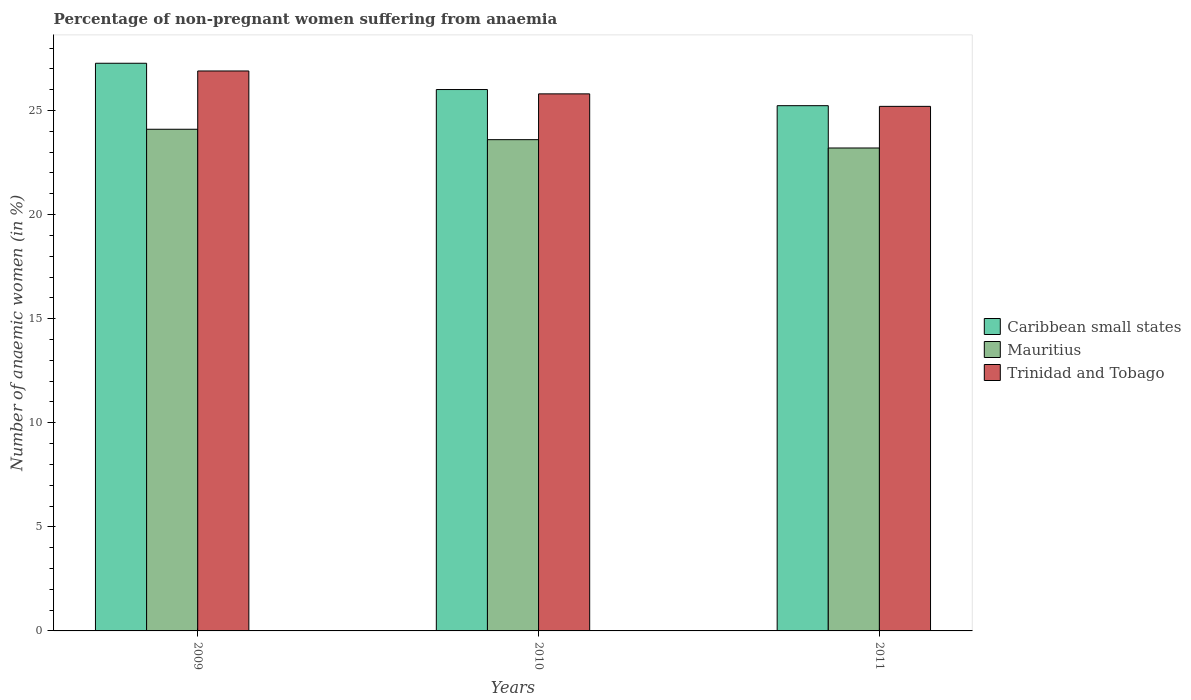Are the number of bars per tick equal to the number of legend labels?
Your answer should be very brief. Yes. What is the percentage of non-pregnant women suffering from anaemia in Trinidad and Tobago in 2010?
Provide a succinct answer. 25.8. Across all years, what is the maximum percentage of non-pregnant women suffering from anaemia in Caribbean small states?
Keep it short and to the point. 27.27. Across all years, what is the minimum percentage of non-pregnant women suffering from anaemia in Mauritius?
Provide a succinct answer. 23.2. What is the total percentage of non-pregnant women suffering from anaemia in Mauritius in the graph?
Your answer should be compact. 70.9. What is the difference between the percentage of non-pregnant women suffering from anaemia in Trinidad and Tobago in 2010 and that in 2011?
Offer a terse response. 0.6. What is the difference between the percentage of non-pregnant women suffering from anaemia in Caribbean small states in 2011 and the percentage of non-pregnant women suffering from anaemia in Trinidad and Tobago in 2010?
Your answer should be very brief. -0.57. What is the average percentage of non-pregnant women suffering from anaemia in Trinidad and Tobago per year?
Provide a short and direct response. 25.97. In the year 2009, what is the difference between the percentage of non-pregnant women suffering from anaemia in Mauritius and percentage of non-pregnant women suffering from anaemia in Caribbean small states?
Your response must be concise. -3.17. What is the ratio of the percentage of non-pregnant women suffering from anaemia in Trinidad and Tobago in 2010 to that in 2011?
Your answer should be compact. 1.02. Is the percentage of non-pregnant women suffering from anaemia in Trinidad and Tobago in 2009 less than that in 2011?
Your answer should be very brief. No. What is the difference between the highest and the second highest percentage of non-pregnant women suffering from anaemia in Caribbean small states?
Provide a succinct answer. 1.26. What is the difference between the highest and the lowest percentage of non-pregnant women suffering from anaemia in Trinidad and Tobago?
Your answer should be compact. 1.7. What does the 2nd bar from the left in 2010 represents?
Your answer should be very brief. Mauritius. What does the 3rd bar from the right in 2011 represents?
Offer a very short reply. Caribbean small states. How many bars are there?
Give a very brief answer. 9. Are all the bars in the graph horizontal?
Provide a succinct answer. No. How many years are there in the graph?
Your response must be concise. 3. What is the difference between two consecutive major ticks on the Y-axis?
Offer a terse response. 5. Does the graph contain any zero values?
Keep it short and to the point. No. How are the legend labels stacked?
Provide a succinct answer. Vertical. What is the title of the graph?
Provide a succinct answer. Percentage of non-pregnant women suffering from anaemia. What is the label or title of the X-axis?
Give a very brief answer. Years. What is the label or title of the Y-axis?
Your answer should be compact. Number of anaemic women (in %). What is the Number of anaemic women (in %) of Caribbean small states in 2009?
Your answer should be very brief. 27.27. What is the Number of anaemic women (in %) in Mauritius in 2009?
Keep it short and to the point. 24.1. What is the Number of anaemic women (in %) of Trinidad and Tobago in 2009?
Make the answer very short. 26.9. What is the Number of anaemic women (in %) in Caribbean small states in 2010?
Offer a very short reply. 26.01. What is the Number of anaemic women (in %) of Mauritius in 2010?
Give a very brief answer. 23.6. What is the Number of anaemic women (in %) of Trinidad and Tobago in 2010?
Your answer should be very brief. 25.8. What is the Number of anaemic women (in %) of Caribbean small states in 2011?
Give a very brief answer. 25.23. What is the Number of anaemic women (in %) of Mauritius in 2011?
Your answer should be very brief. 23.2. What is the Number of anaemic women (in %) in Trinidad and Tobago in 2011?
Give a very brief answer. 25.2. Across all years, what is the maximum Number of anaemic women (in %) of Caribbean small states?
Give a very brief answer. 27.27. Across all years, what is the maximum Number of anaemic women (in %) in Mauritius?
Your answer should be compact. 24.1. Across all years, what is the maximum Number of anaemic women (in %) in Trinidad and Tobago?
Your answer should be very brief. 26.9. Across all years, what is the minimum Number of anaemic women (in %) of Caribbean small states?
Your answer should be compact. 25.23. Across all years, what is the minimum Number of anaemic women (in %) of Mauritius?
Your answer should be compact. 23.2. Across all years, what is the minimum Number of anaemic women (in %) in Trinidad and Tobago?
Your response must be concise. 25.2. What is the total Number of anaemic women (in %) of Caribbean small states in the graph?
Keep it short and to the point. 78.51. What is the total Number of anaemic women (in %) of Mauritius in the graph?
Keep it short and to the point. 70.9. What is the total Number of anaemic women (in %) in Trinidad and Tobago in the graph?
Offer a terse response. 77.9. What is the difference between the Number of anaemic women (in %) in Caribbean small states in 2009 and that in 2010?
Ensure brevity in your answer.  1.26. What is the difference between the Number of anaemic women (in %) in Caribbean small states in 2009 and that in 2011?
Your answer should be compact. 2.04. What is the difference between the Number of anaemic women (in %) in Mauritius in 2009 and that in 2011?
Your answer should be very brief. 0.9. What is the difference between the Number of anaemic women (in %) in Trinidad and Tobago in 2009 and that in 2011?
Provide a succinct answer. 1.7. What is the difference between the Number of anaemic women (in %) in Caribbean small states in 2010 and that in 2011?
Offer a very short reply. 0.78. What is the difference between the Number of anaemic women (in %) of Caribbean small states in 2009 and the Number of anaemic women (in %) of Mauritius in 2010?
Your answer should be very brief. 3.67. What is the difference between the Number of anaemic women (in %) of Caribbean small states in 2009 and the Number of anaemic women (in %) of Trinidad and Tobago in 2010?
Your answer should be compact. 1.47. What is the difference between the Number of anaemic women (in %) of Mauritius in 2009 and the Number of anaemic women (in %) of Trinidad and Tobago in 2010?
Your answer should be very brief. -1.7. What is the difference between the Number of anaemic women (in %) of Caribbean small states in 2009 and the Number of anaemic women (in %) of Mauritius in 2011?
Your answer should be compact. 4.07. What is the difference between the Number of anaemic women (in %) in Caribbean small states in 2009 and the Number of anaemic women (in %) in Trinidad and Tobago in 2011?
Offer a very short reply. 2.07. What is the difference between the Number of anaemic women (in %) of Caribbean small states in 2010 and the Number of anaemic women (in %) of Mauritius in 2011?
Your response must be concise. 2.81. What is the difference between the Number of anaemic women (in %) in Caribbean small states in 2010 and the Number of anaemic women (in %) in Trinidad and Tobago in 2011?
Offer a terse response. 0.81. What is the difference between the Number of anaemic women (in %) of Mauritius in 2010 and the Number of anaemic women (in %) of Trinidad and Tobago in 2011?
Ensure brevity in your answer.  -1.6. What is the average Number of anaemic women (in %) of Caribbean small states per year?
Offer a very short reply. 26.17. What is the average Number of anaemic women (in %) of Mauritius per year?
Keep it short and to the point. 23.63. What is the average Number of anaemic women (in %) of Trinidad and Tobago per year?
Keep it short and to the point. 25.97. In the year 2009, what is the difference between the Number of anaemic women (in %) of Caribbean small states and Number of anaemic women (in %) of Mauritius?
Offer a very short reply. 3.17. In the year 2009, what is the difference between the Number of anaemic women (in %) in Caribbean small states and Number of anaemic women (in %) in Trinidad and Tobago?
Ensure brevity in your answer.  0.37. In the year 2009, what is the difference between the Number of anaemic women (in %) in Mauritius and Number of anaemic women (in %) in Trinidad and Tobago?
Your answer should be very brief. -2.8. In the year 2010, what is the difference between the Number of anaemic women (in %) of Caribbean small states and Number of anaemic women (in %) of Mauritius?
Offer a terse response. 2.41. In the year 2010, what is the difference between the Number of anaemic women (in %) in Caribbean small states and Number of anaemic women (in %) in Trinidad and Tobago?
Your answer should be very brief. 0.21. In the year 2010, what is the difference between the Number of anaemic women (in %) of Mauritius and Number of anaemic women (in %) of Trinidad and Tobago?
Offer a very short reply. -2.2. In the year 2011, what is the difference between the Number of anaemic women (in %) of Caribbean small states and Number of anaemic women (in %) of Mauritius?
Provide a succinct answer. 2.03. In the year 2011, what is the difference between the Number of anaemic women (in %) in Caribbean small states and Number of anaemic women (in %) in Trinidad and Tobago?
Keep it short and to the point. 0.03. What is the ratio of the Number of anaemic women (in %) in Caribbean small states in 2009 to that in 2010?
Provide a succinct answer. 1.05. What is the ratio of the Number of anaemic women (in %) of Mauritius in 2009 to that in 2010?
Provide a succinct answer. 1.02. What is the ratio of the Number of anaemic women (in %) in Trinidad and Tobago in 2009 to that in 2010?
Provide a short and direct response. 1.04. What is the ratio of the Number of anaemic women (in %) of Caribbean small states in 2009 to that in 2011?
Offer a terse response. 1.08. What is the ratio of the Number of anaemic women (in %) of Mauritius in 2009 to that in 2011?
Your answer should be compact. 1.04. What is the ratio of the Number of anaemic women (in %) of Trinidad and Tobago in 2009 to that in 2011?
Ensure brevity in your answer.  1.07. What is the ratio of the Number of anaemic women (in %) in Caribbean small states in 2010 to that in 2011?
Your answer should be compact. 1.03. What is the ratio of the Number of anaemic women (in %) in Mauritius in 2010 to that in 2011?
Provide a short and direct response. 1.02. What is the ratio of the Number of anaemic women (in %) in Trinidad and Tobago in 2010 to that in 2011?
Provide a short and direct response. 1.02. What is the difference between the highest and the second highest Number of anaemic women (in %) in Caribbean small states?
Provide a short and direct response. 1.26. What is the difference between the highest and the second highest Number of anaemic women (in %) in Mauritius?
Give a very brief answer. 0.5. What is the difference between the highest and the lowest Number of anaemic women (in %) in Caribbean small states?
Your answer should be compact. 2.04. What is the difference between the highest and the lowest Number of anaemic women (in %) of Mauritius?
Give a very brief answer. 0.9. What is the difference between the highest and the lowest Number of anaemic women (in %) in Trinidad and Tobago?
Your answer should be compact. 1.7. 